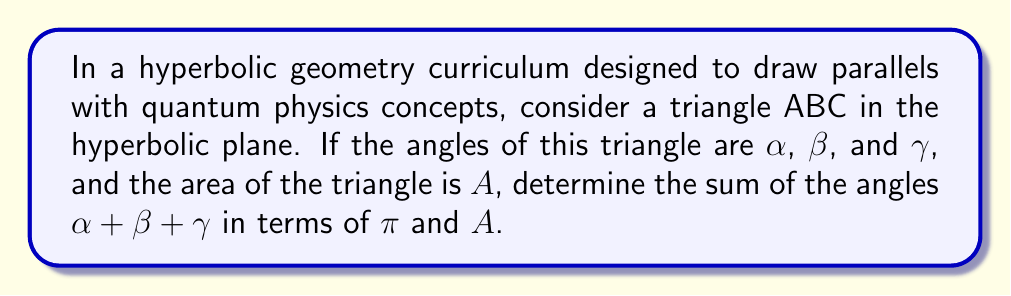Show me your answer to this math problem. Let's approach this step-by-step:

1) In Euclidean geometry, we know that the sum of angles in a triangle is always $\pi$ radians or 180°. However, in hyperbolic geometry, this is not the case.

2) In hyperbolic geometry, there's a fundamental relationship between the area of a triangle and the sum of its angles. This relationship is given by the Gauss-Bonnet theorem for hyperbolic triangles:

   $$A = \pi - (\alpha + \beta + \gamma)$$

   Where $A$ is the area of the triangle, and $\alpha$, $\beta$, and $\gamma$ are the angles of the triangle.

3) To find the sum of the angles, we need to rearrange this equation:

   $$\pi - A = \alpha + \beta + \gamma$$

4) Therefore, the sum of the angles in a hyperbolic triangle is always less than $\pi$ radians (or 180°), and the difference between $\pi$ and this sum is equal to the area of the triangle.

5) This result has interesting parallels with quantum physics, particularly in the concept of curvature in spacetime, which is central to general relativity and quantum gravity theories.
Answer: $\pi - A$ 